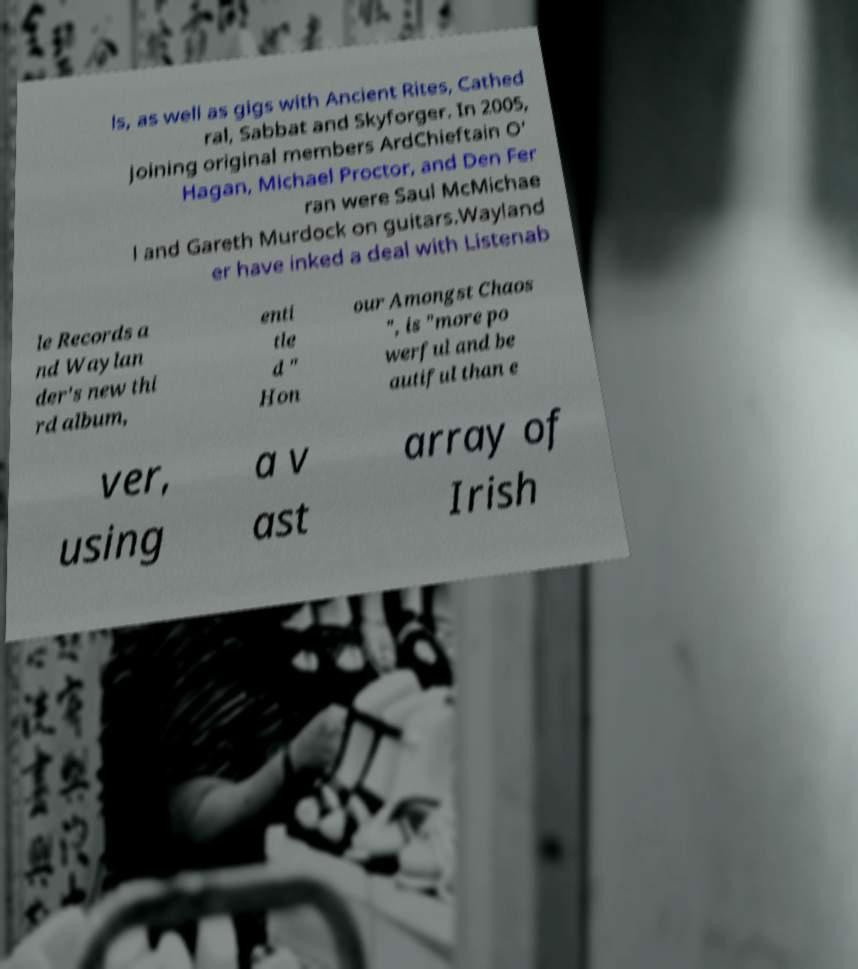What messages or text are displayed in this image? I need them in a readable, typed format. ls, as well as gigs with Ancient Rites, Cathed ral, Sabbat and Skyforger. In 2005, joining original members ArdChieftain O' Hagan, Michael Proctor, and Den Fer ran were Saul McMichae l and Gareth Murdock on guitars.Wayland er have inked a deal with Listenab le Records a nd Waylan der's new thi rd album, enti tle d " Hon our Amongst Chaos ", is "more po werful and be autiful than e ver, using a v ast array of Irish 